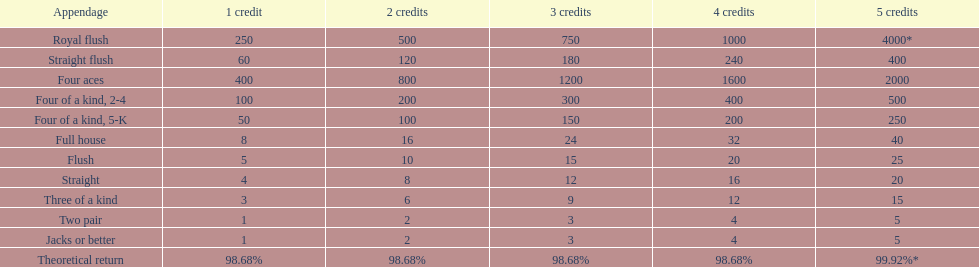Which hand is the top hand in the card game super aces? Royal flush. 